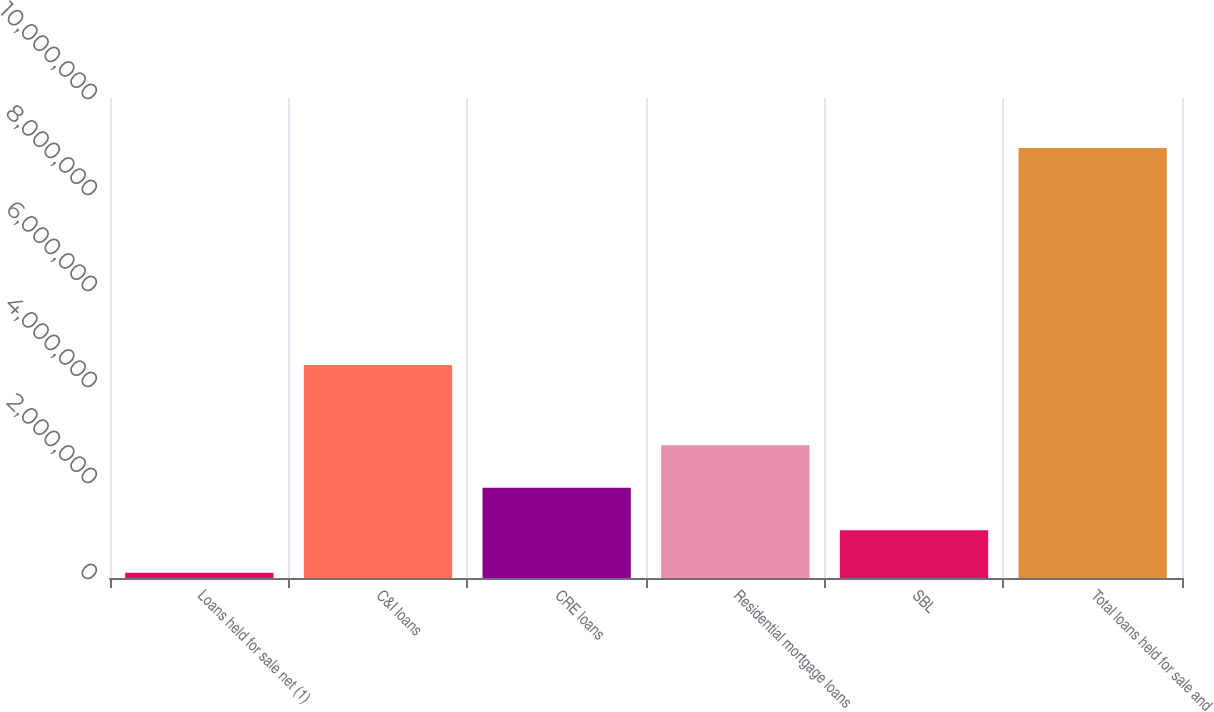Convert chart to OTSL. <chart><loc_0><loc_0><loc_500><loc_500><bar_chart><fcel>Loans held for sale net (1)<fcel>C&I loans<fcel>CRE loans<fcel>Residential mortgage loans<fcel>SBL<fcel>Total loans held for sale and<nl><fcel>110292<fcel>4.43967e+06<fcel>1.87977e+06<fcel>2.76452e+06<fcel>995033<fcel>8.9577e+06<nl></chart> 